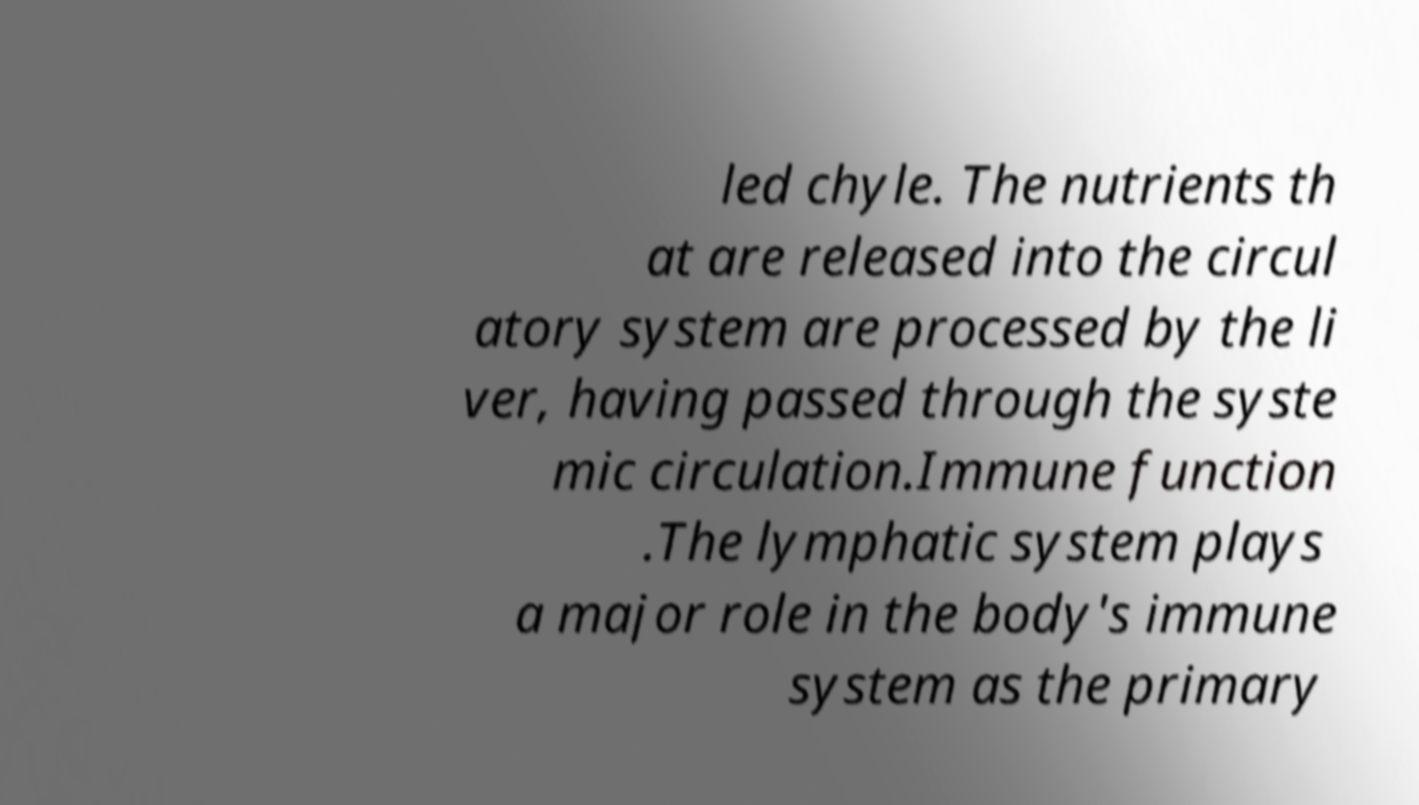Could you extract and type out the text from this image? led chyle. The nutrients th at are released into the circul atory system are processed by the li ver, having passed through the syste mic circulation.Immune function .The lymphatic system plays a major role in the body's immune system as the primary 